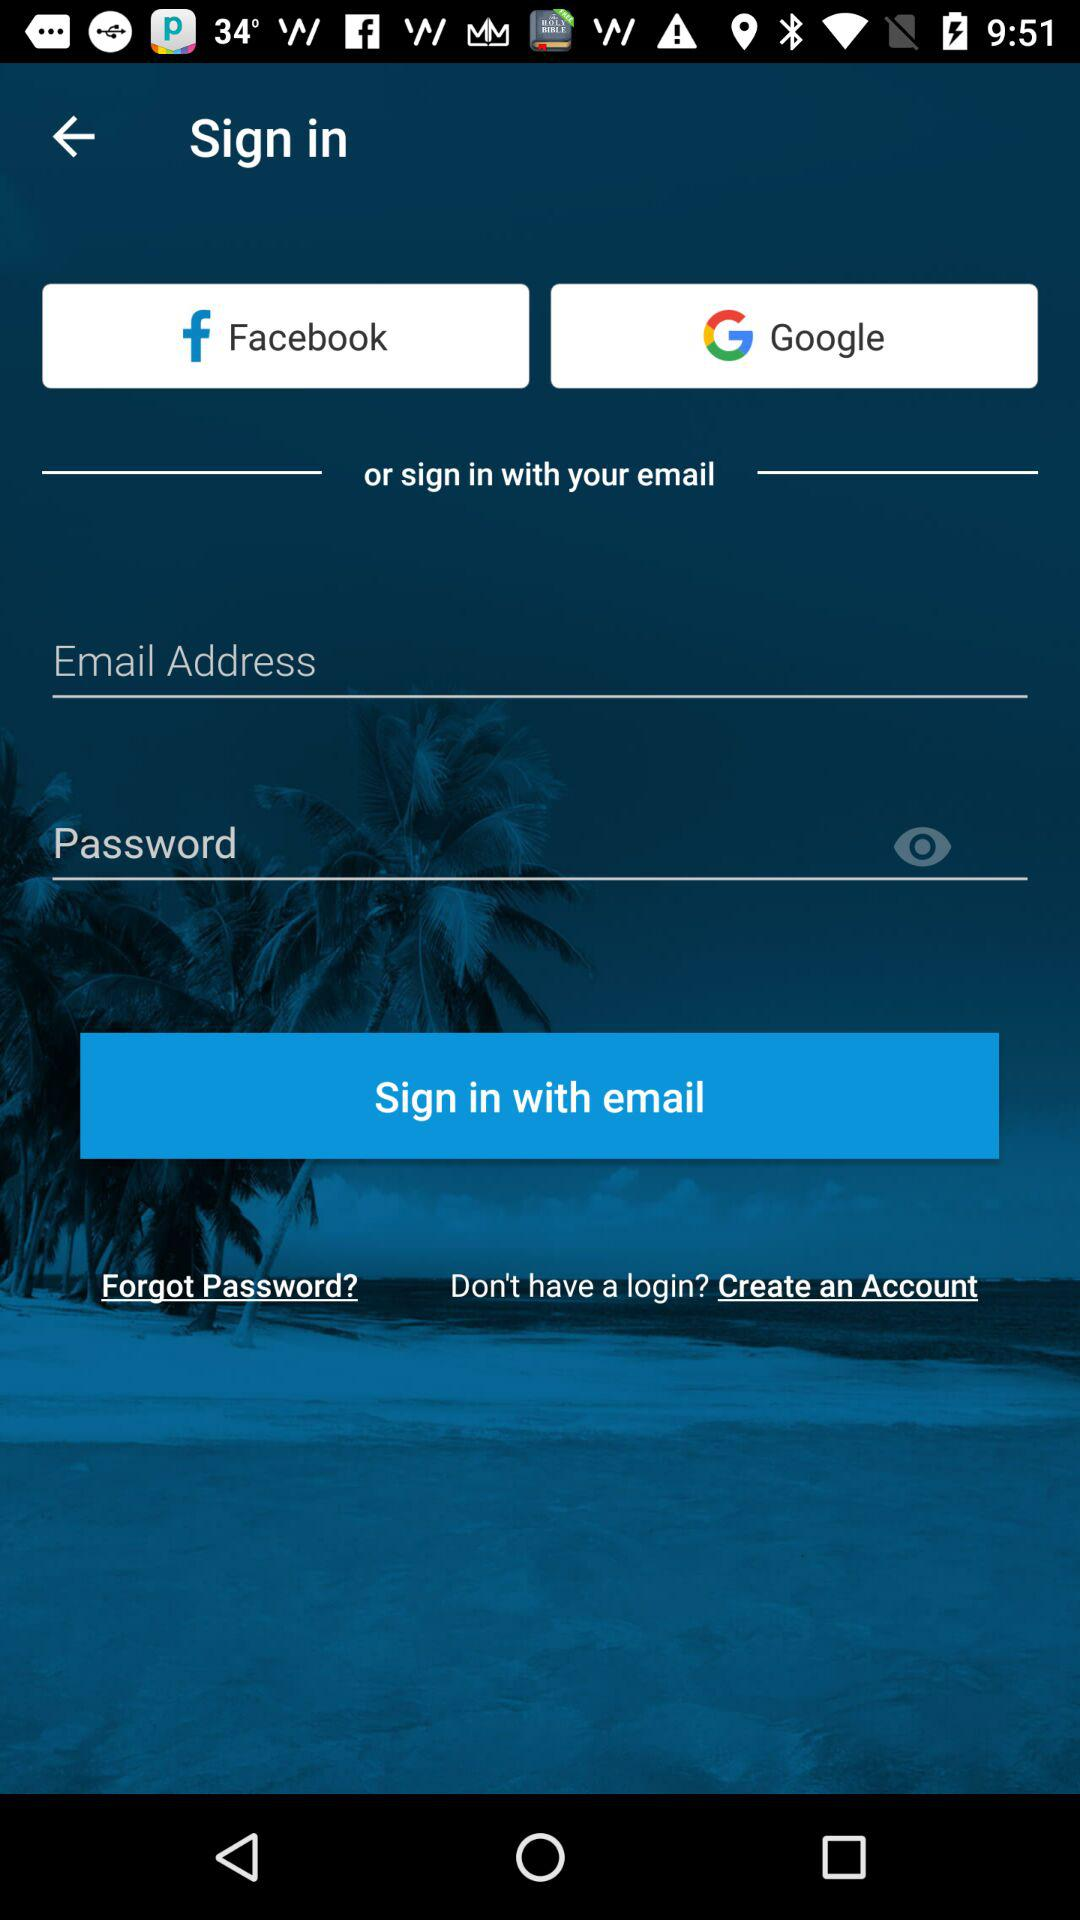What accounts can I use to sign in? The accounts you can use to sign in are "Facebook", "Google" and "email". 